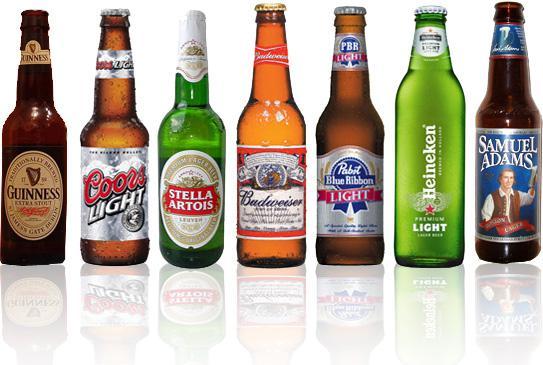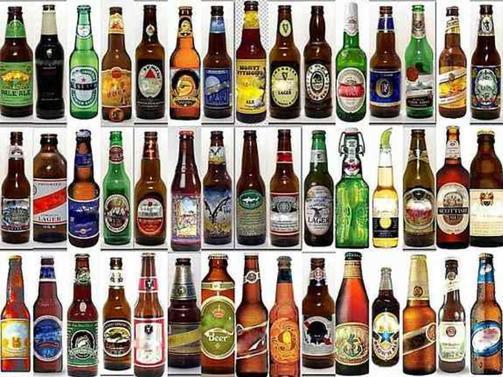The first image is the image on the left, the second image is the image on the right. Examine the images to the left and right. Is the description "One of the images includes fewer than eight bottles in total." accurate? Answer yes or no. Yes. 